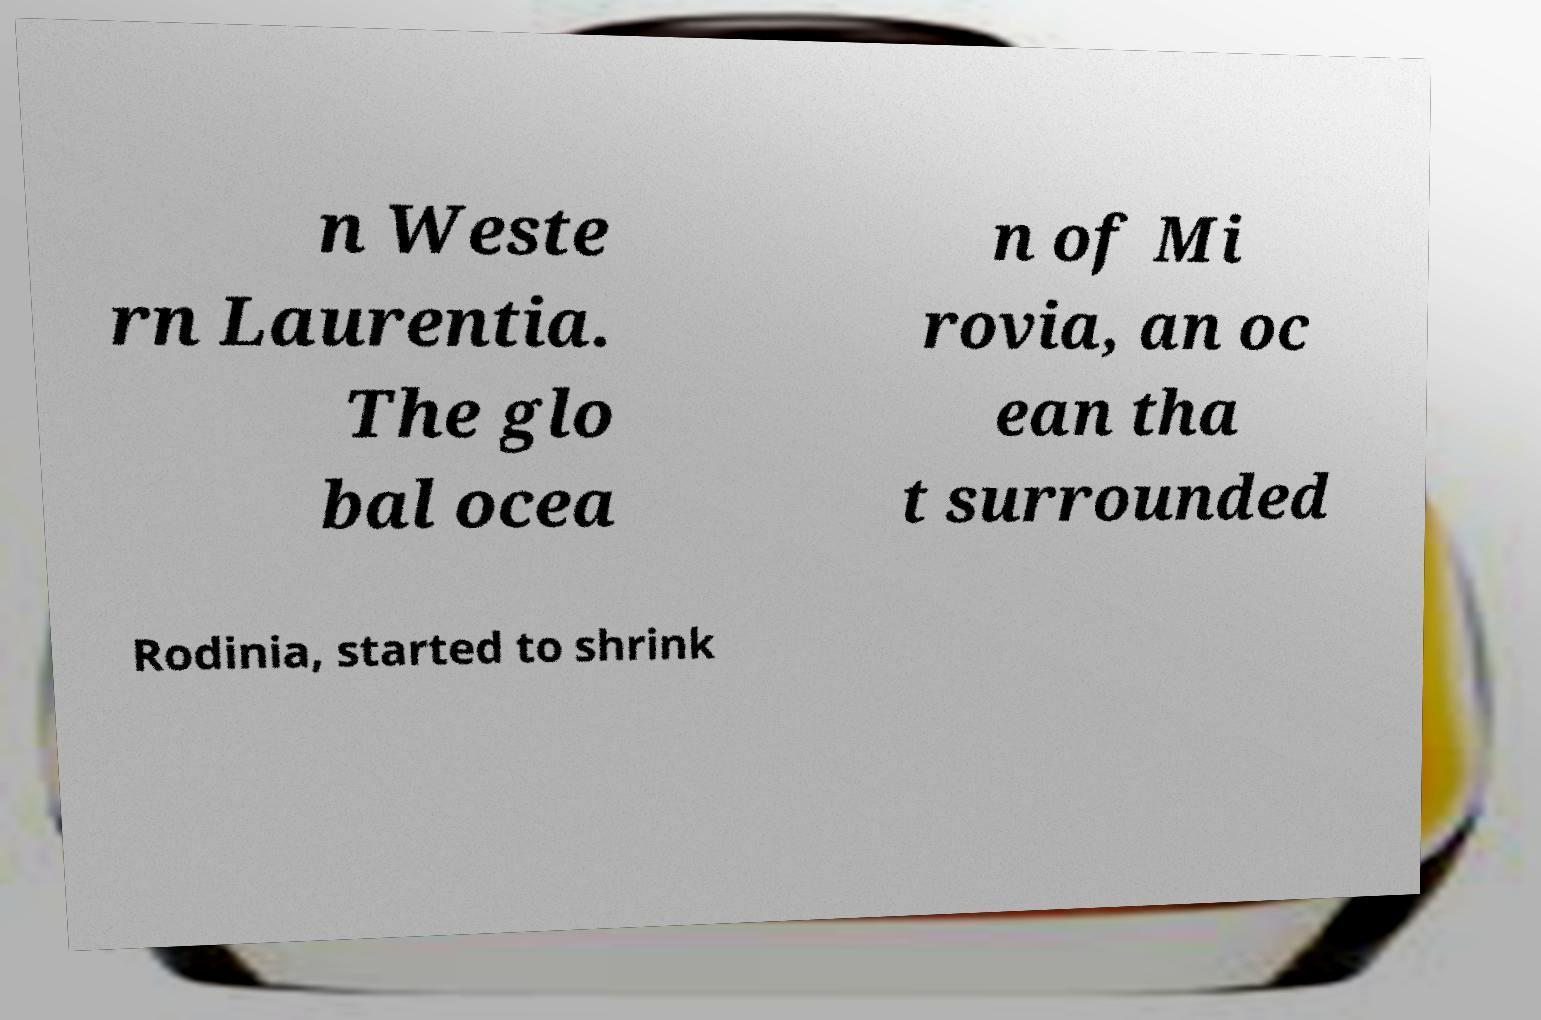Could you extract and type out the text from this image? n Weste rn Laurentia. The glo bal ocea n of Mi rovia, an oc ean tha t surrounded Rodinia, started to shrink 